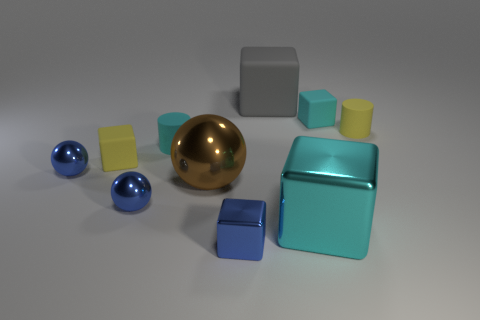Subtract all yellow blocks. How many blocks are left? 4 Subtract all yellow cubes. How many cubes are left? 4 Subtract all red blocks. Subtract all cyan balls. How many blocks are left? 5 Subtract all cylinders. How many objects are left? 8 Add 3 large brown objects. How many large brown objects are left? 4 Add 1 small brown cylinders. How many small brown cylinders exist? 1 Subtract 0 red cylinders. How many objects are left? 10 Subtract all small cubes. Subtract all brown rubber cylinders. How many objects are left? 7 